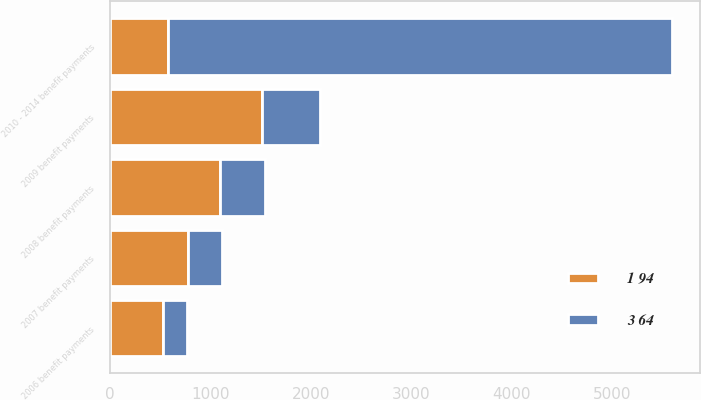<chart> <loc_0><loc_0><loc_500><loc_500><stacked_bar_chart><ecel><fcel>2006 benefit payments<fcel>2007 benefit payments<fcel>2008 benefit payments<fcel>2009 benefit payments<fcel>2010 - 2014 benefit payments<nl><fcel>1 94<fcel>526<fcel>778<fcel>1093<fcel>1511<fcel>583<nl><fcel>3 64<fcel>244<fcel>339<fcel>448<fcel>583<fcel>5008<nl></chart> 